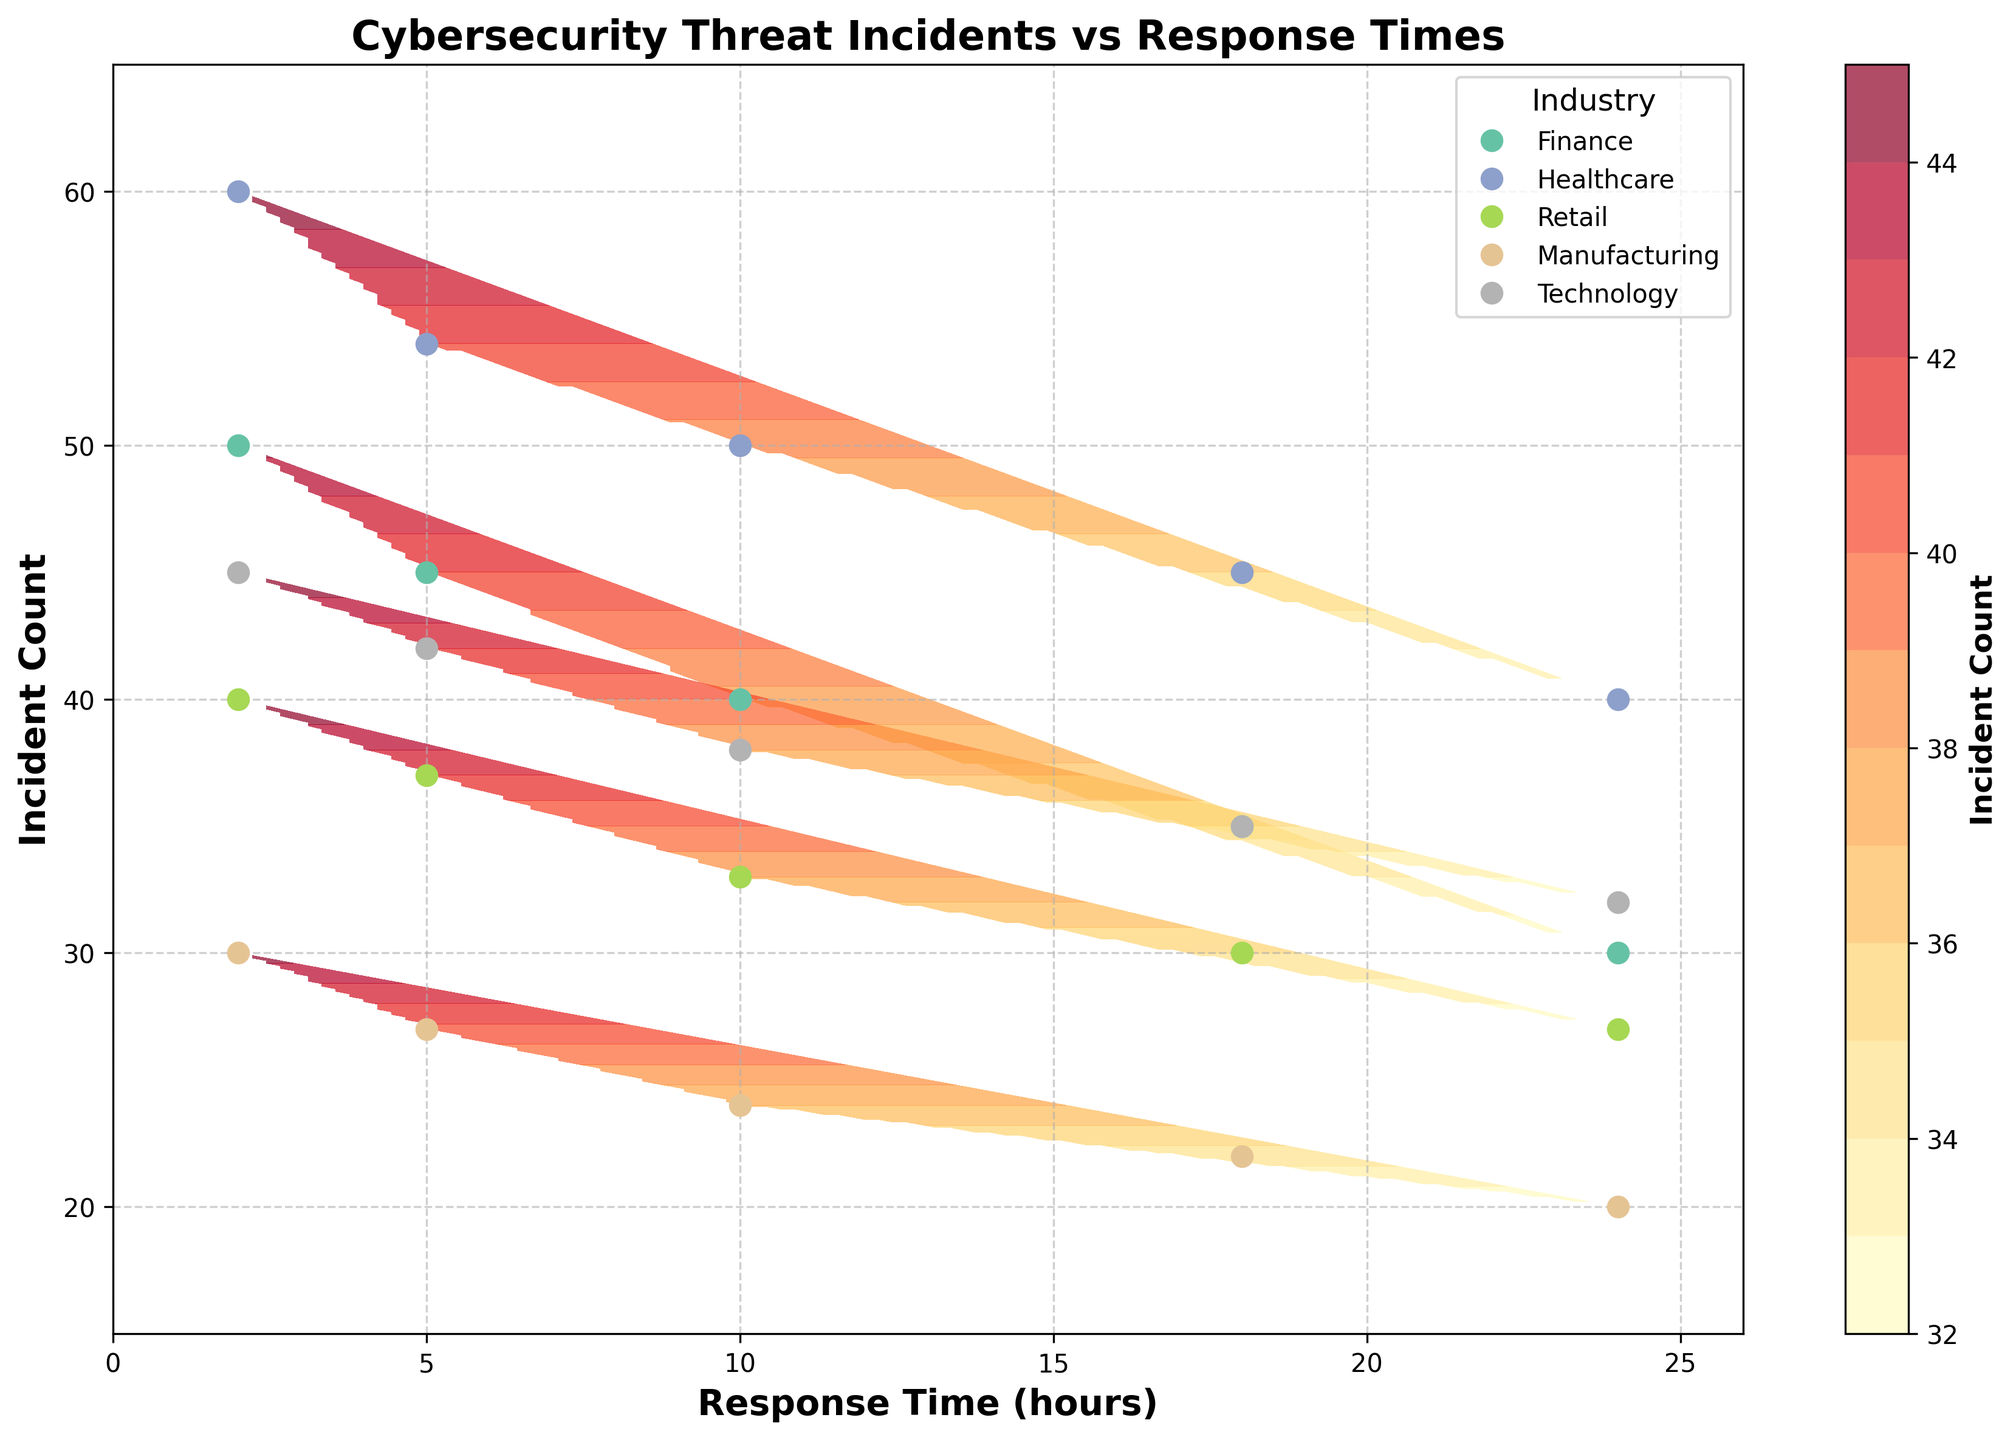What is the title of the figure? The title of the figure is written at the top and provides an overview of the visualized data. Reading the top of the figure provides the title.
Answer: Cybersecurity Threat Incidents vs Response Times What does the color bar represent? The color bar typically indicates the intensity or value range of a specific variable in the contour plot. The label next to the color bar provides this information.
Answer: Incident Count How many industries are represented in the plot? The legend in the plot indicates the different industries represented by different colors. Counting the distinct labels in the legend gives the answer.
Answer: Five Which industry has the highest incident count at a 2-hour response time? By looking at the plot, we can see the position of each industry's data points. Identifying the mark at the 2-hour response time and comparing the incident counts will yield the answer.
Answer: Healthcare Which industry shows the largest decrease in incident count from a 2-hour to a 24-hour response time? Each industry's trend over the response times can be observed. Calculating the decrease for each and comparing them helps identify the largest drop.
Answer: Healthcare In which range of response times do the incident counts for the Retail industry vary? Observing the incident counts' range for data points labeled as Retail along the x-axis (response time) helps identify this range.
Answer: 27 to 40 incidents Does any industry show an increasing trend in incident count as response time increases? Observing the direction of the data points for each industry along the x-axis will indicate whether there's an increasing trend in incident count with increasing response time.
Answer: No Compare the response times of the Finance and Technology industries that have approximately 35 incident counts. Which is faster? Finding the data points for both Finance and Technology around the 35 incident count mark and comparing their corresponding response times will give the answer.
Answer: Finance What is the general trend observed across all industries between response time and incident count? The overall pattern of the data points for each industry will show whether incident count increases or decreases as response time increases.
Answer: Incident count decreases with increasing response time What is the incident count for Manufacturing at a 10-hour response time? Finding the Manufacturing data point corresponding to a 10-hour response time will provide the incident count.
Answer: 24 